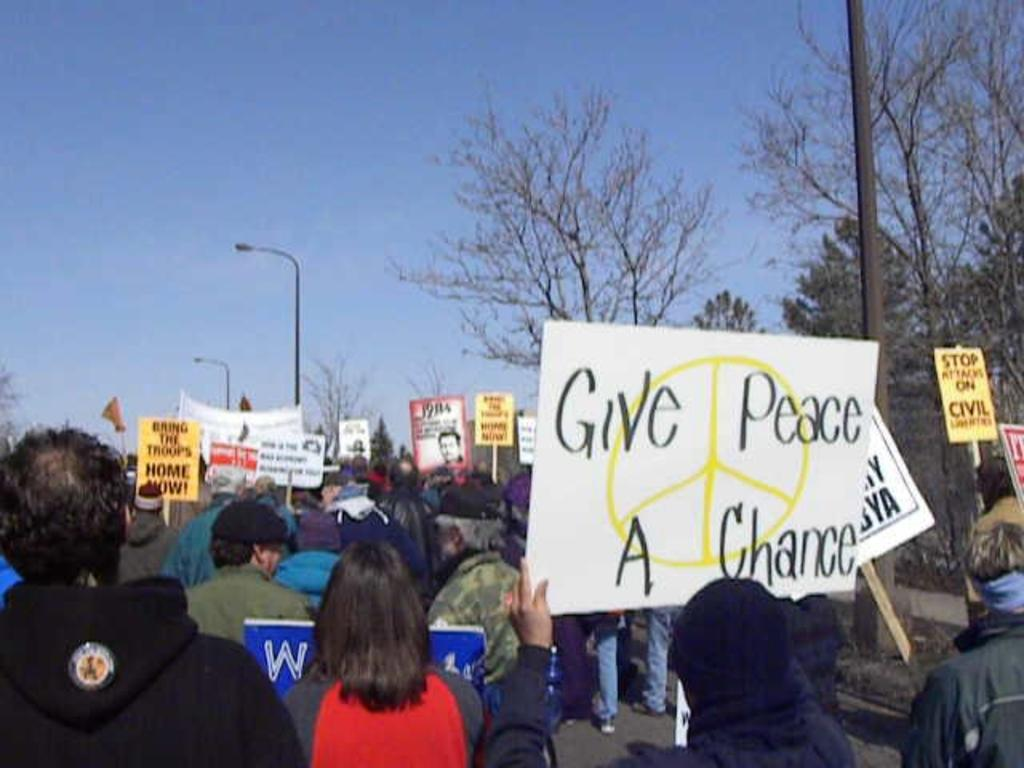Provide a one-sentence caption for the provided image. A protest in which signs are held promoting peace. 